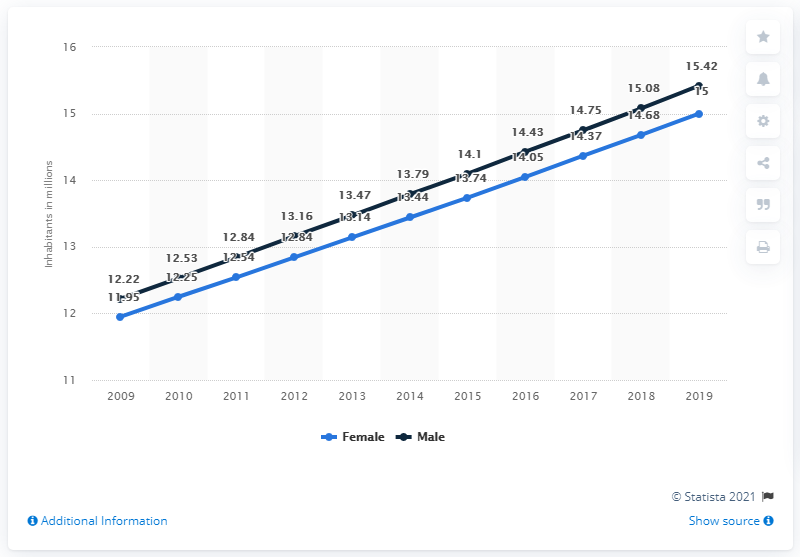Identify some key points in this picture. In 2019, the female population of Ghana was approximately 15 million. In 2019, the male population of Ghana was 15.42 million. 